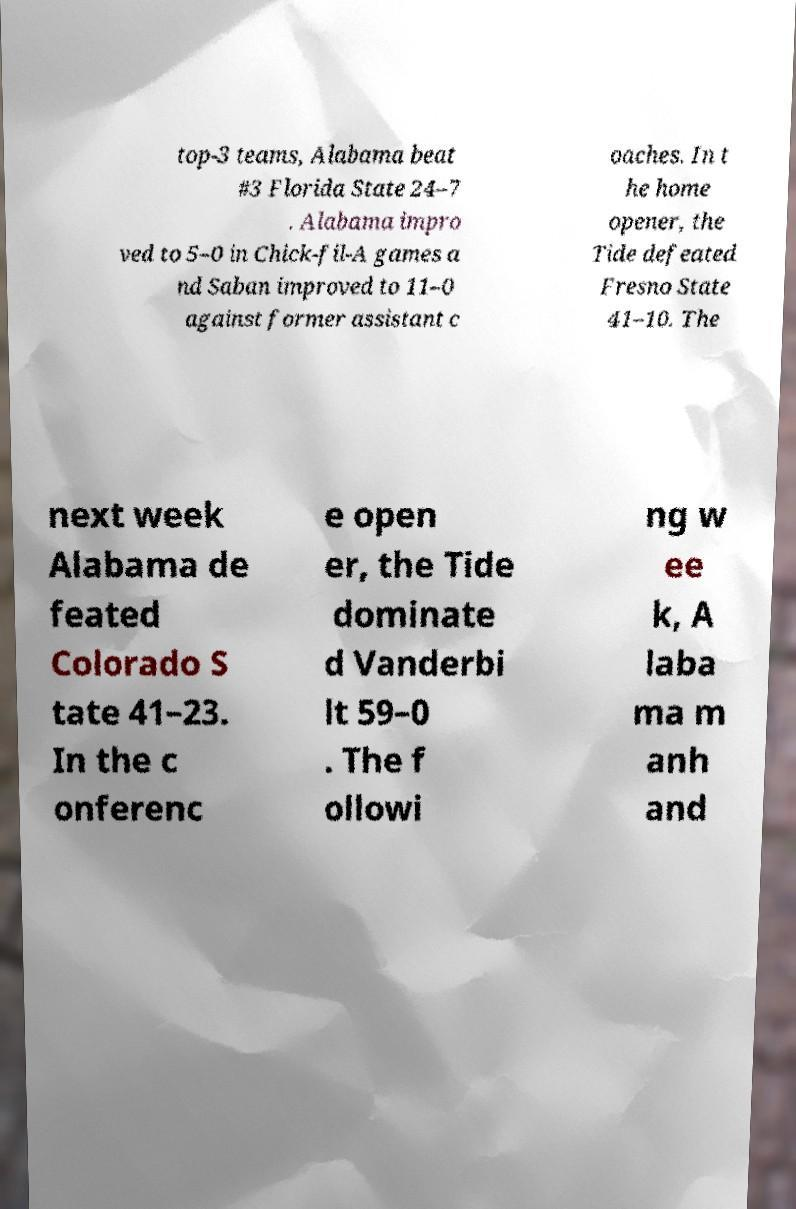Please read and relay the text visible in this image. What does it say? top-3 teams, Alabama beat #3 Florida State 24–7 . Alabama impro ved to 5–0 in Chick-fil-A games a nd Saban improved to 11–0 against former assistant c oaches. In t he home opener, the Tide defeated Fresno State 41–10. The next week Alabama de feated Colorado S tate 41–23. In the c onferenc e open er, the Tide dominate d Vanderbi lt 59–0 . The f ollowi ng w ee k, A laba ma m anh and 